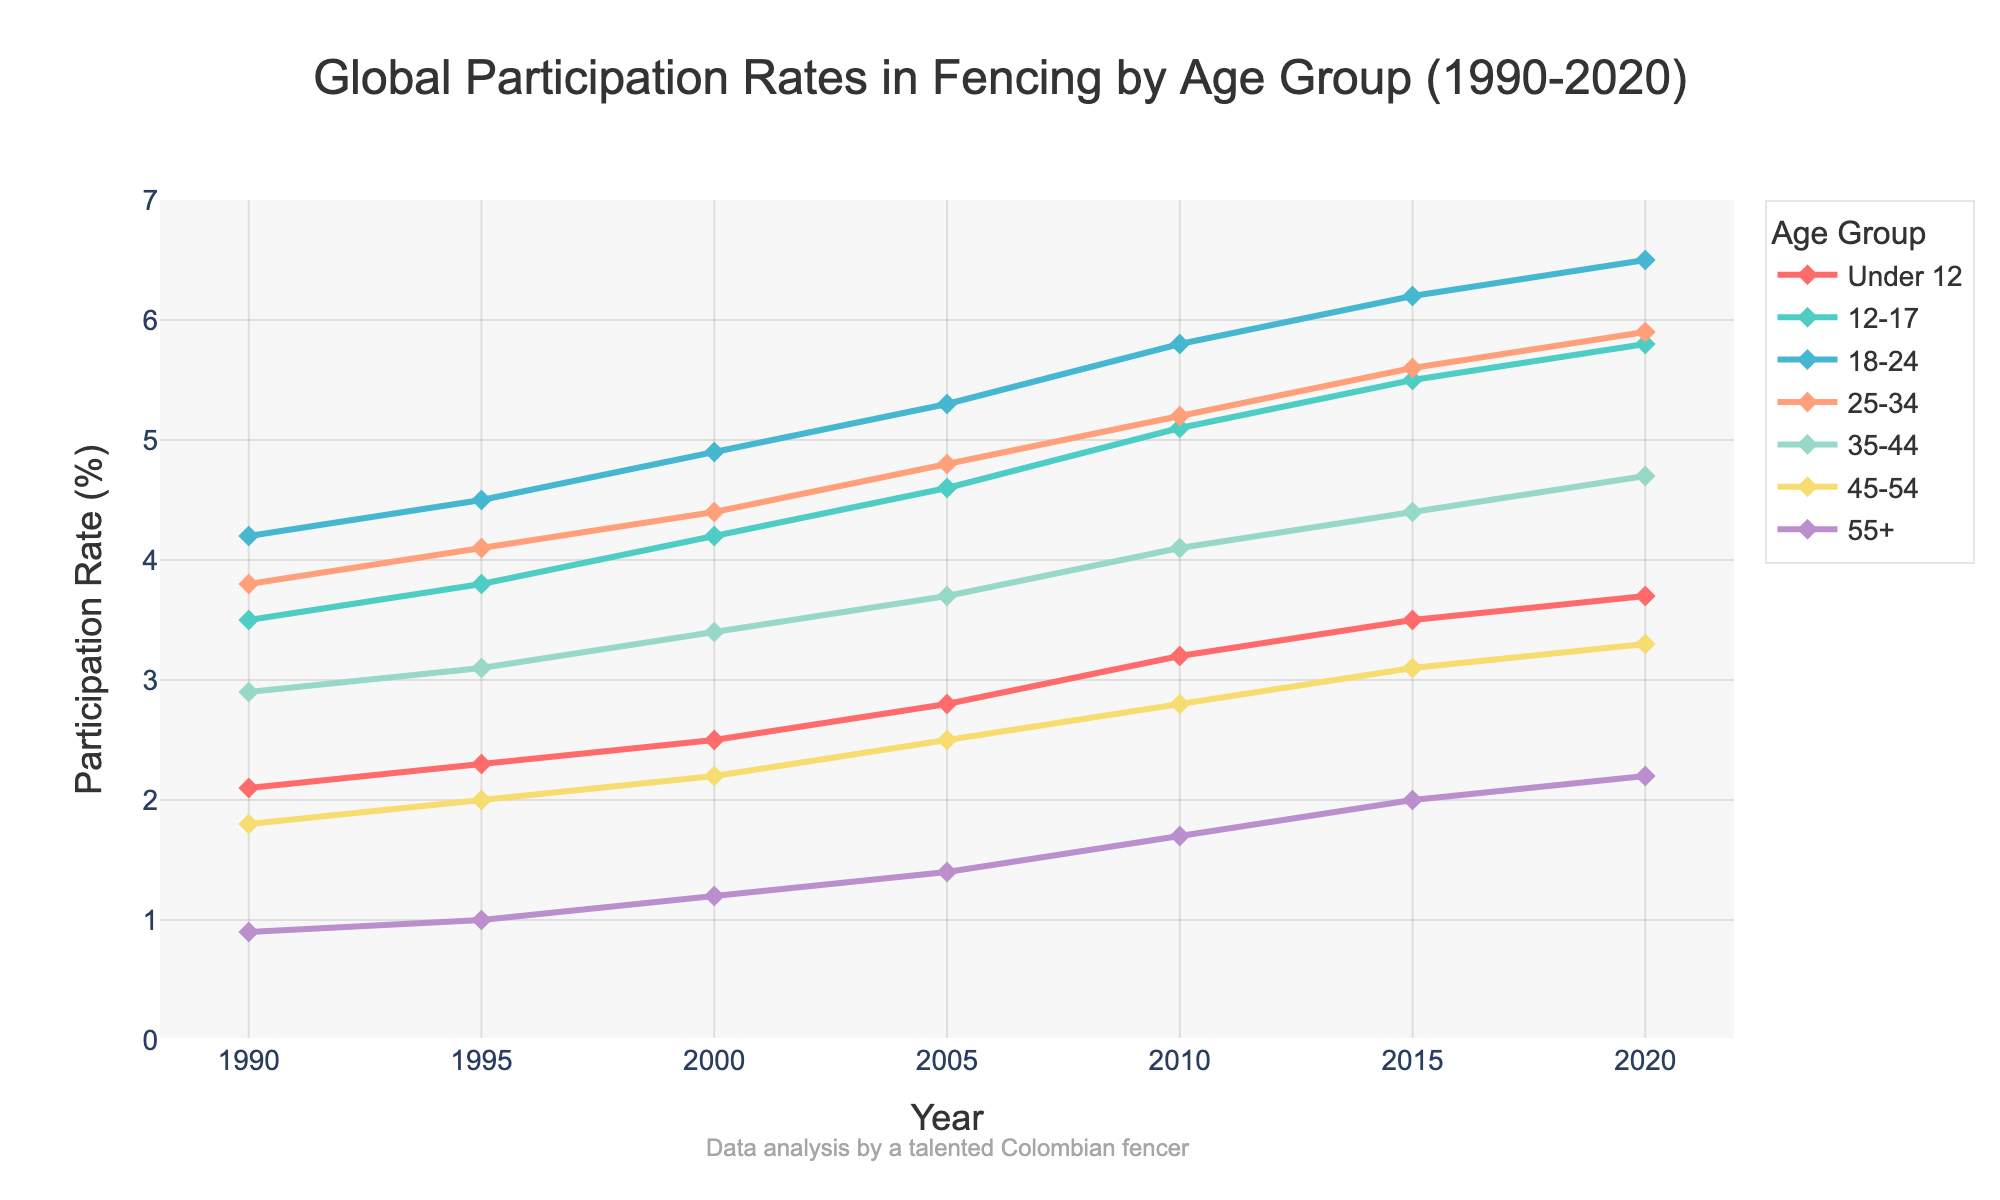What's the overall trend in global participation rates in fencing for the age group "Under 12" between 1990 and 2020? The line representing the "Under 12" age group shows an upward trend from 1990 to 2020, as the participation rate increased from 2.1% in 1990 to 3.7% in 2020.
Answer: Upward trend Which age group had the highest participation rate in 2020? Looking at the plot, the line for the age group "18-24" is at the highest point in 2020 with a participation rate of 6.5%.
Answer: 18-24 How did the participation rate of the "45-54" age group change from 1995 to 2005? The participation rate for the "45-54" age group increased from 2.0% in 1995 to 2.5% in 2005. To find the change, subtract 2.0 from 2.5, which equals 0.5.
Answer: Increased by 0.5% Between which two consecutive years did the "12-17" age group see the largest increase in participation rates? For the "12-17" age group, calculate the differences between consecutive years. The largest increase is from 2000 (4.2%) to 2005 (4.6%), which is an increase of 0.4%.
Answer: 2000 to 2005 Which age group had the smallest participation rate in 1990, and what was the rate? The age group "55+" had the smallest participation rate in 1990 at 0.9%, as seen at the lowest point in the plot for that year.
Answer: 55+, 0.9% What is the average participation rate change for the "35-44" age group from 1990 to 2020? Calculate the change for each time interval and then find the average. Changes are: (3.1 - 2.9), (3.4 - 3.1), (3.7 - 3.4), (4.1 - 3.7), (4.4 - 4.1), (4.7 - 4.4); sum = 1.8, average change = 1.8/6 = 0.3%.
Answer: 0.3% Between 1990 and 2010, which age group saw the highest absolute increase in participation rates? Calculate the increase for each age group: 
Under 12: (3.2 - 2.1) = 1.1% 
12-17: (5.1 - 3.5) = 1.6% 
18-24: (5.8 - 4.2) = 1.6% 
25-34: (5.2 - 3.8) = 1.4% 
35-44: (4.1 - 2.9) = 1.2%
45-54: (2.8 - 1.8) = 1.0% 
55+: (1.7 - 0.9) = 0.8%.
Both "12-17" and "18-24" saw the highest increase of 1.6%.
Answer: 12-17 and 18-24, 1.6% Which age group's participation rate closely followed the trend of the "25-34" age group over the years? By comparing the trends, the age group "18-24" closely followed the "25-34" trend with both showing a fairly steady increase and similar gradient changes over the years.
Answer: 18-24 What was the range of participation rates for the "55+" age group in the entire time period? The range is found by subtracting the minimum value (0.9% in 1990) from the maximum value (2.2% in 2020), giving a range of 1.3%.
Answer: 1.3% 